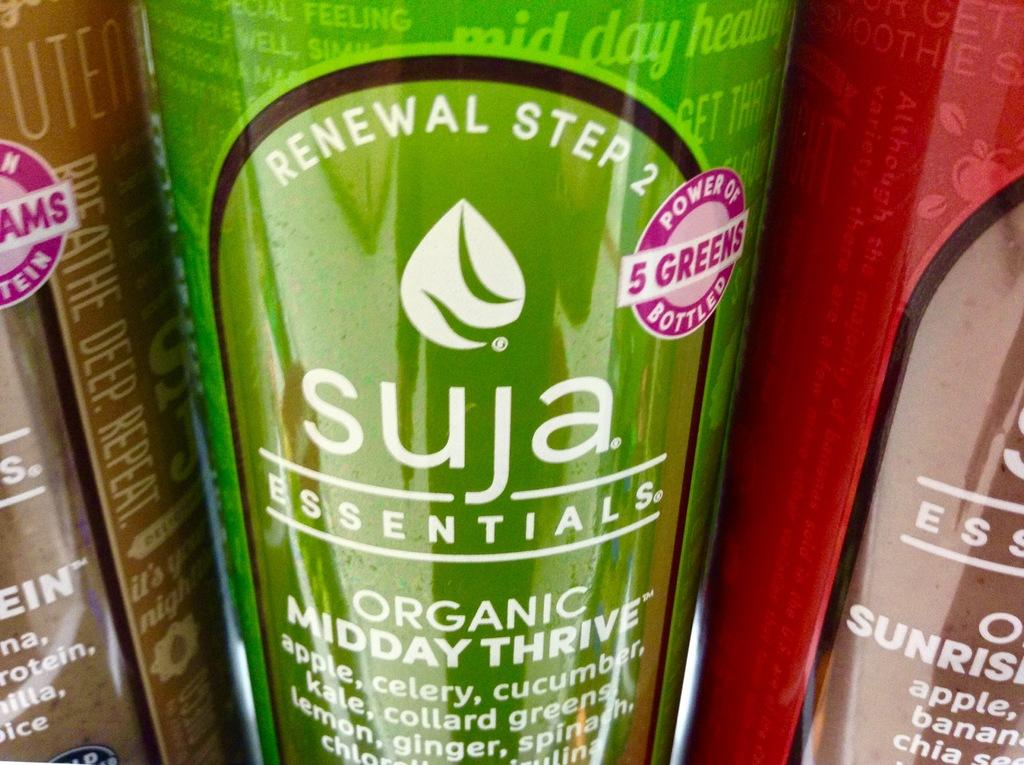How many bottles are visible in the image? There are three bottles in the image. What colors are the bottles? One bottle is brown, one is green, and one is red. What type of farmer is shown working in the field in the image? There is no farmer or field present in the image; it only features three bottles of different colors. 